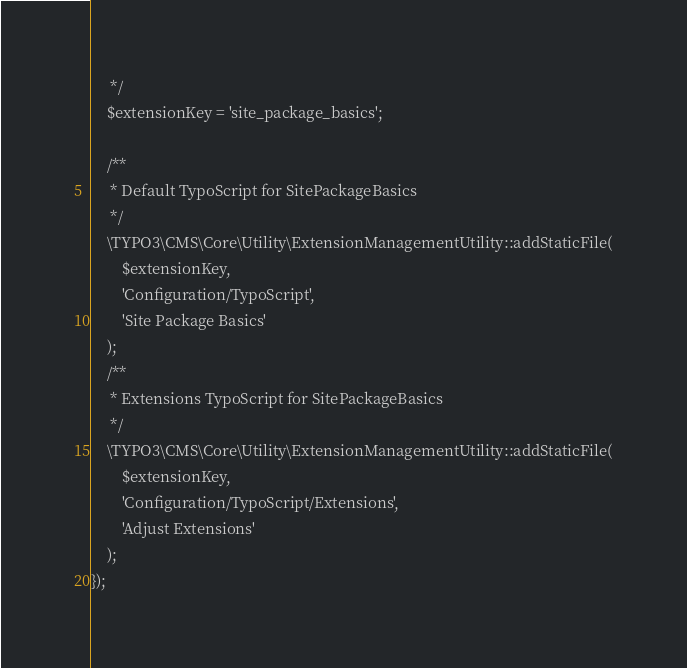<code> <loc_0><loc_0><loc_500><loc_500><_PHP_>     */
    $extensionKey = 'site_package_basics';

    /**
     * Default TypoScript for SitePackageBasics
     */
    \TYPO3\CMS\Core\Utility\ExtensionManagementUtility::addStaticFile(
        $extensionKey,
        'Configuration/TypoScript',
        'Site Package Basics'
    );
    /**
     * Extensions TypoScript for SitePackageBasics
     */
    \TYPO3\CMS\Core\Utility\ExtensionManagementUtility::addStaticFile(
        $extensionKey,
        'Configuration/TypoScript/Extensions',
        'Adjust Extensions'
    );
});
</code> 